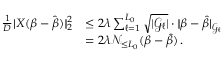<formula> <loc_0><loc_0><loc_500><loc_500>\begin{array} { r l } { \frac { 1 } { D } | \, | X ( \beta - \hat { \beta } ) | \, | _ { 2 } ^ { 2 } } & { \leq 2 \lambda \sum _ { \ell = 1 } ^ { L _ { 0 } } \sqrt { | { \mathcal { G } } _ { \ell } | } \cdot | \, | \beta - \hat { \beta } | \, | _ { { \mathcal { G } } _ { \ell } } } \\ & { = 2 \lambda { \mathcal { N } } _ { \leq L _ { 0 } } ( \beta - \hat { \beta } ) \, . } \end{array}</formula> 